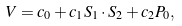Convert formula to latex. <formula><loc_0><loc_0><loc_500><loc_500>V = c _ { 0 } + c _ { 1 } S _ { 1 } \cdot S _ { 2 } + c _ { 2 } P _ { 0 } ,</formula> 